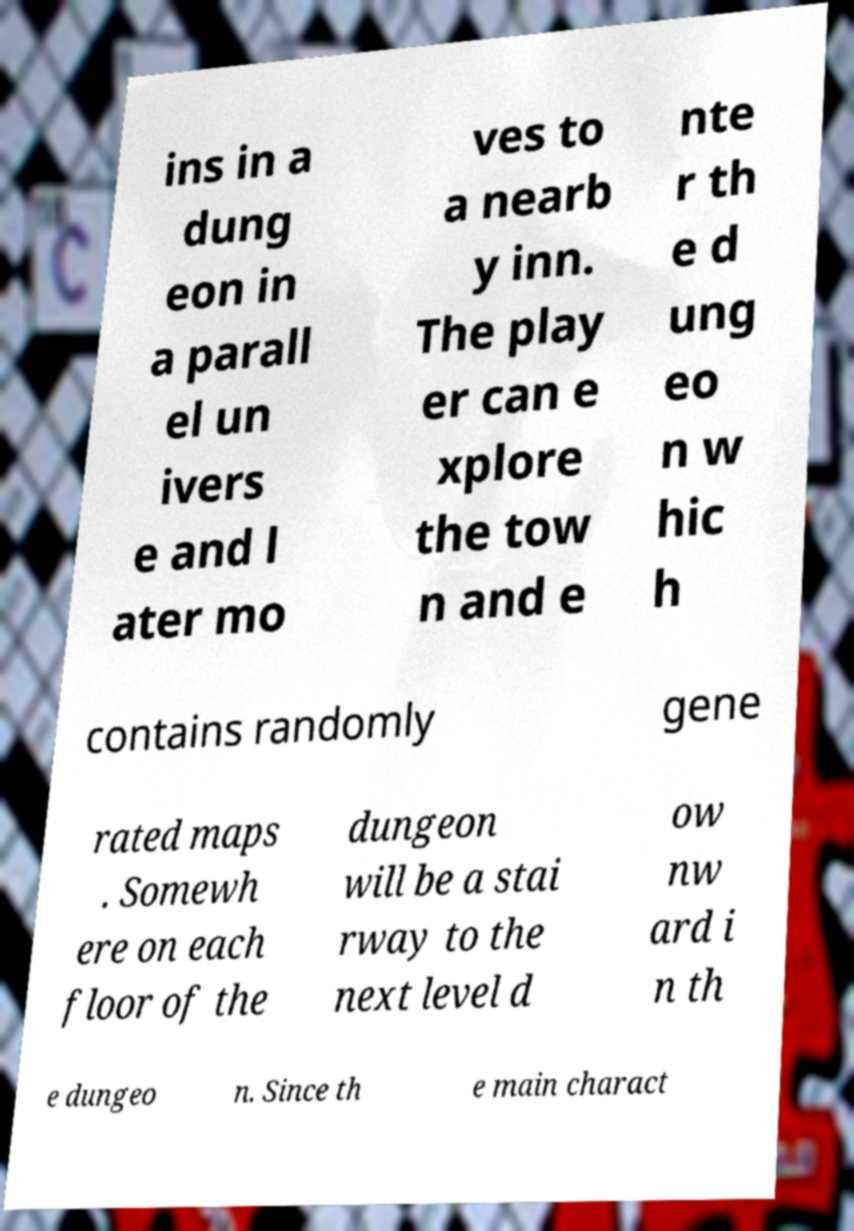Could you extract and type out the text from this image? ins in a dung eon in a parall el un ivers e and l ater mo ves to a nearb y inn. The play er can e xplore the tow n and e nte r th e d ung eo n w hic h contains randomly gene rated maps . Somewh ere on each floor of the dungeon will be a stai rway to the next level d ow nw ard i n th e dungeo n. Since th e main charact 